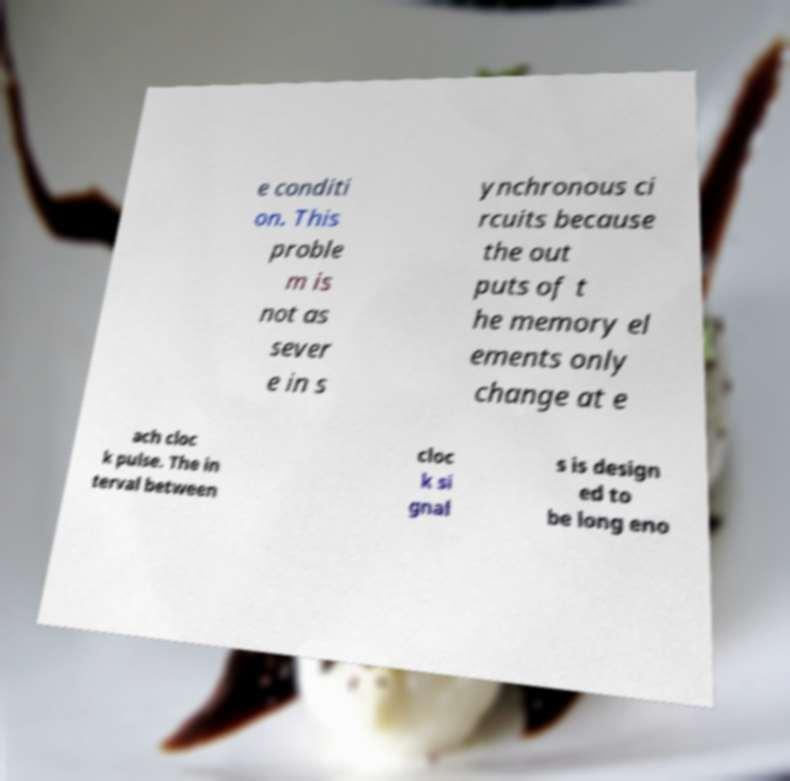What messages or text are displayed in this image? I need them in a readable, typed format. e conditi on. This proble m is not as sever e in s ynchronous ci rcuits because the out puts of t he memory el ements only change at e ach cloc k pulse. The in terval between cloc k si gnal s is design ed to be long eno 